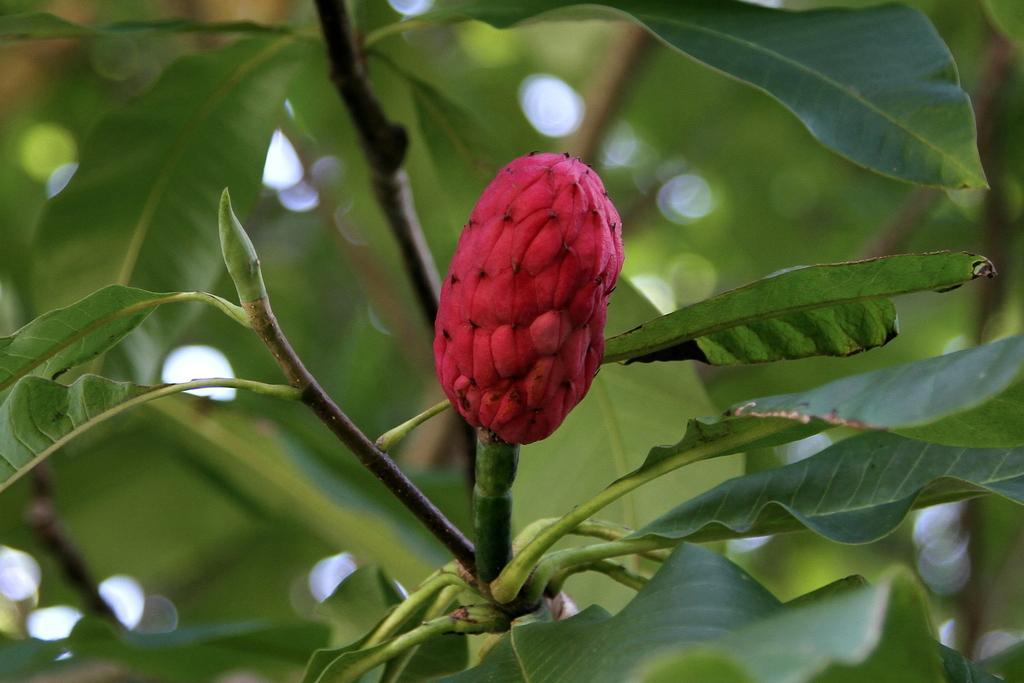Can you describe this image briefly? In front of the image there is a stem with leaves and a bud. Behind the bud there are leaves and also there is a green color blur background. 